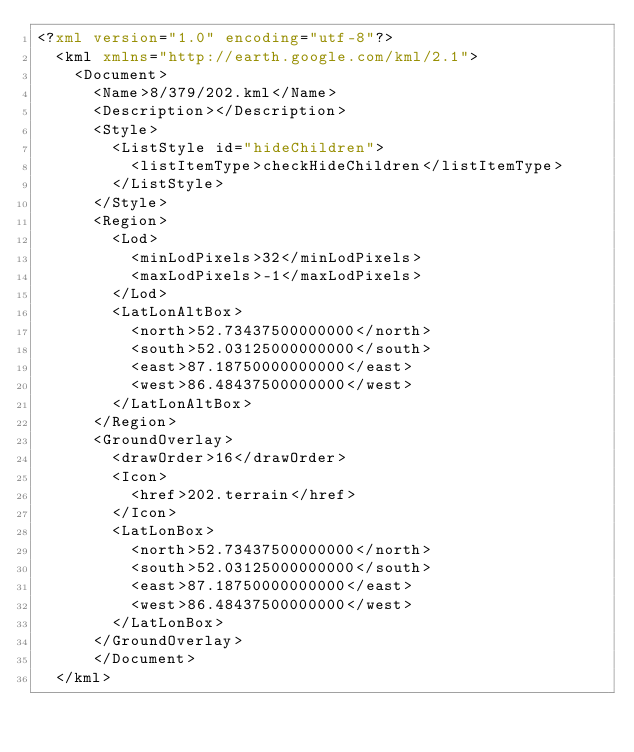<code> <loc_0><loc_0><loc_500><loc_500><_XML_><?xml version="1.0" encoding="utf-8"?>
	<kml xmlns="http://earth.google.com/kml/2.1">
	  <Document>
	    <Name>8/379/202.kml</Name>
	    <Description></Description>
	    <Style>
	      <ListStyle id="hideChildren">
	        <listItemType>checkHideChildren</listItemType>
	      </ListStyle>
	    </Style>
	    <Region>
	      <Lod>
	        <minLodPixels>32</minLodPixels>
	        <maxLodPixels>-1</maxLodPixels>
	      </Lod>
	      <LatLonAltBox>
	        <north>52.73437500000000</north>
	        <south>52.03125000000000</south>
	        <east>87.18750000000000</east>
	        <west>86.48437500000000</west>
	      </LatLonAltBox>
	    </Region>
	    <GroundOverlay>
	      <drawOrder>16</drawOrder>
	      <Icon>
	        <href>202.terrain</href>
	      </Icon>
	      <LatLonBox>
	        <north>52.73437500000000</north>
	        <south>52.03125000000000</south>
	        <east>87.18750000000000</east>
	        <west>86.48437500000000</west>
	      </LatLonBox>
	    </GroundOverlay>
		  </Document>
	</kml>
	</code> 